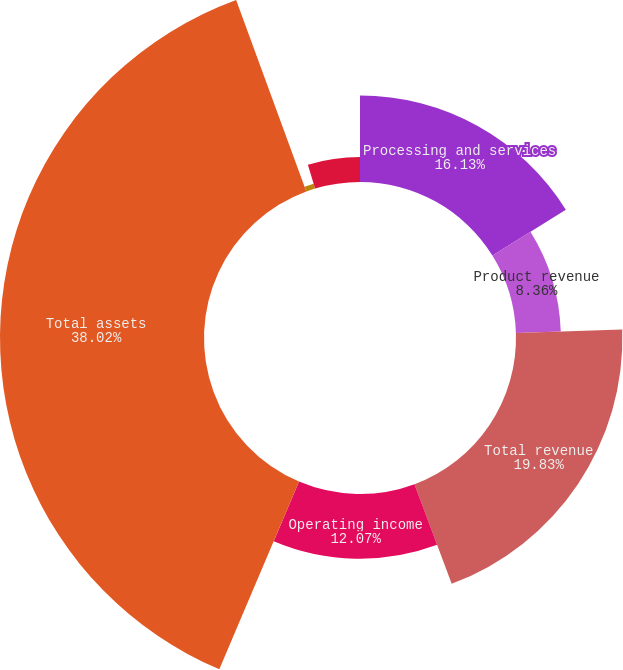Convert chart to OTSL. <chart><loc_0><loc_0><loc_500><loc_500><pie_chart><fcel>Processing and services<fcel>Product revenue<fcel>Total revenue<fcel>Operating income<fcel>Total assets<fcel>Capital expenditures<fcel>Depreciation and amortization<nl><fcel>16.13%<fcel>8.36%<fcel>19.83%<fcel>12.07%<fcel>38.02%<fcel>0.94%<fcel>4.65%<nl></chart> 